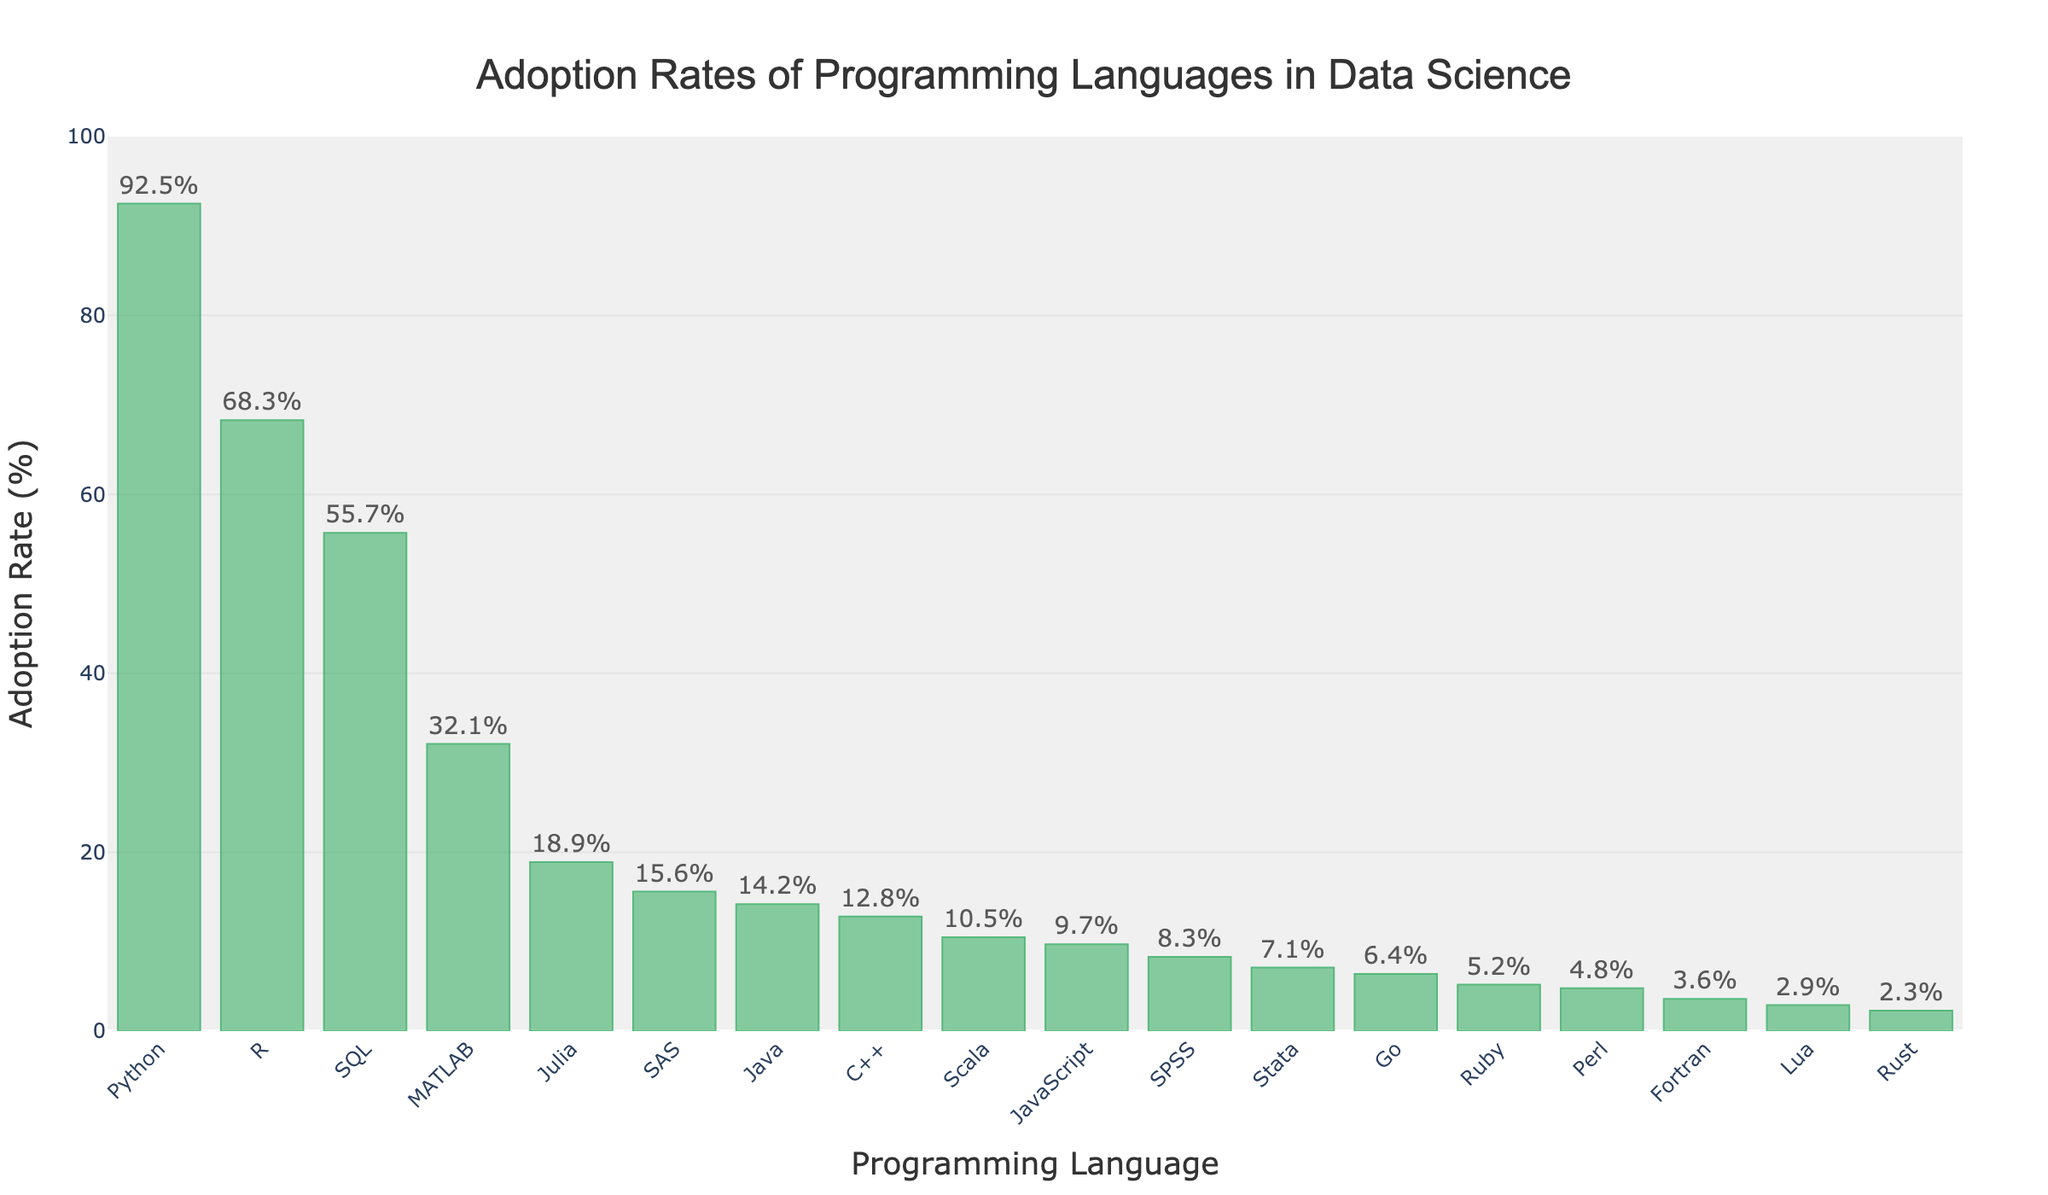Which language has the highest adoption rate? The bar chart shows the height of each bar, with Python having the tallest bar. Therefore, Python has the highest adoption rate.
Answer: Python Which language has a higher adoption rate, R or JavaScript? By comparing the heights of the bars for R and JavaScript, it is clear that R's bar is taller. Therefore, R has a higher adoption rate than JavaScript.
Answer: R What is the difference in adoption rate between SQL and MATLAB? From the bar chart, the adoption rate for SQL is 55.7% and for MATLAB it is 32.1%. The difference is calculated as 55.7 - 32.1.
Answer: 23.6 Which three languages have the lowest adoption rates? By looking for the shortest bars in the chart, the three languages with the shortest bars are Rust, Lua, and Fortran.
Answer: Rust, Lua, Fortran What is the combined adoption rate of Python, R, and SQL? Sum the adoption rates for Python (92.5%), R (68.3%), and SQL (55.7%): 92.5 + 68.3 + 55.7 = 216.5%.
Answer: 216.5 Which has a lower adoption rate, Go or Perl? Comparing the bar heights for Go and Perl, Go's bar is slightly taller than Perl's. Thus, Perl has a lower adoption rate than Go.
Answer: Perl How does the adoption rate of Java compare to that of SAS? Java has an adoption rate of 14.2%, whereas SAS has an adoption rate of 15.6%. So SAS has a higher adoption rate than Java.
Answer: SAS What is the median adoption rate of all the languages? To find the median, list all the adoption rates in ascending order and find the middle value. The sorted adoption rates are: 2.3, 2.9, 3.6, 4.8, 5.2, 6.4, 7.1, 8.3, 9.7, 10.5, 12.8, 14.2, 15.6, 18.9, 32.1, 55.7, 68.3, 92.5. With 18 values, the median is the average of the 9th and 10th values: (9.7 + 10.5)/2 = 10.1.
Answer: 10.1 Does SPSS have a higher or lower adoption rate than Stata? By comparing the bars for SPSS and Stata, it is visible that SPSS's bar is slightly taller than Stata's. Thus, SPSS has a higher adoption rate.
Answer: SPSS What is the range of adoption rates across all languages? The range is the difference between the highest and lowest adoption rates. The highest is Python at 92.5%, and the lowest is Rust at 2.3%. So, the range is 92.5 - 2.3.
Answer: 90.2 